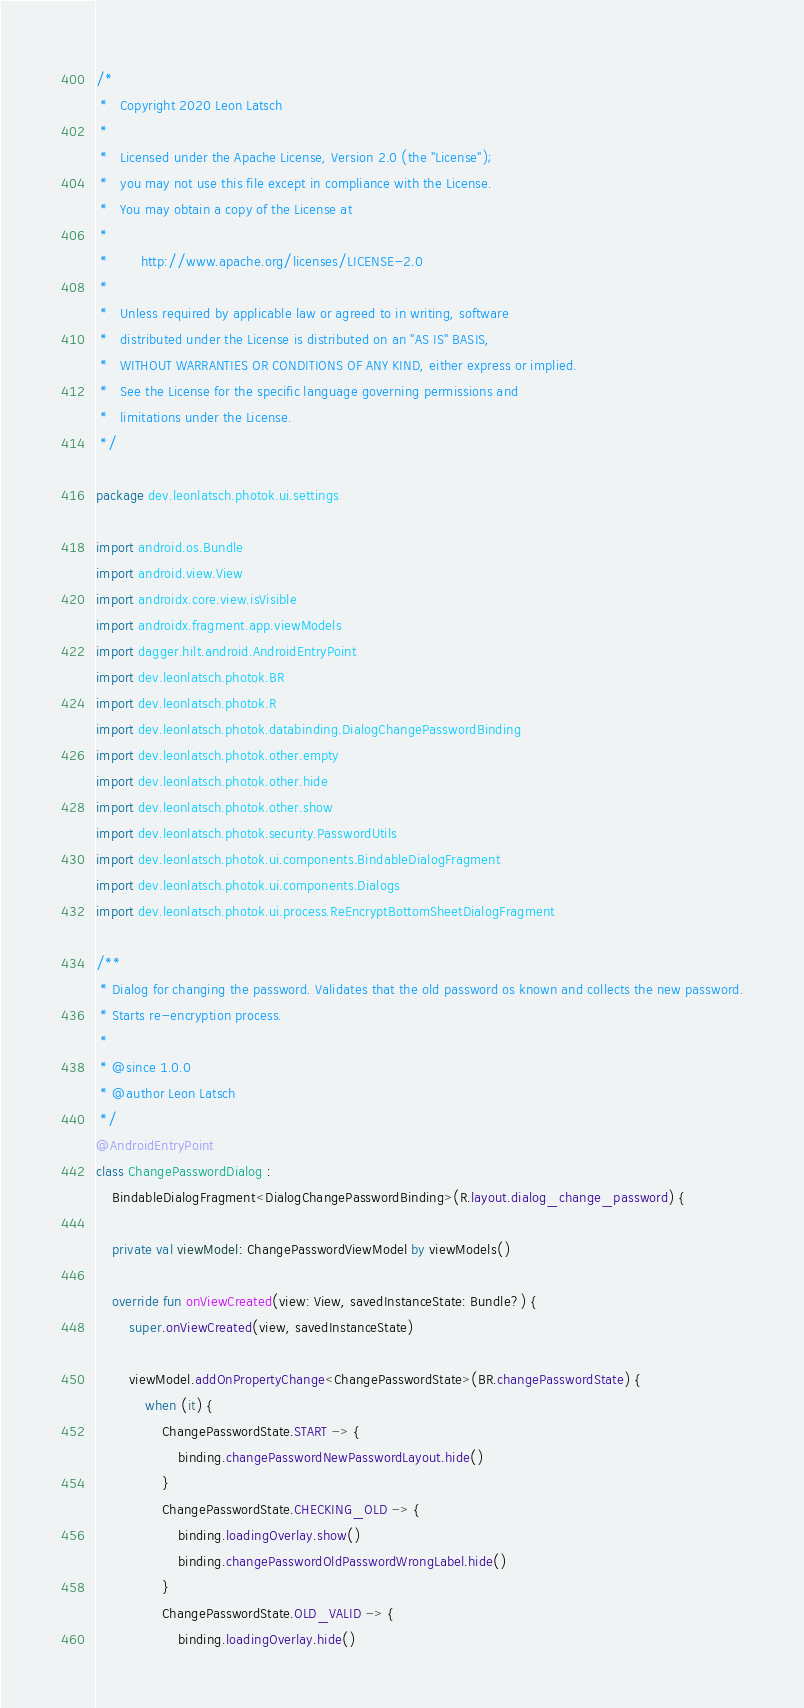Convert code to text. <code><loc_0><loc_0><loc_500><loc_500><_Kotlin_>/*
 *   Copyright 2020 Leon Latsch
 *
 *   Licensed under the Apache License, Version 2.0 (the "License");
 *   you may not use this file except in compliance with the License.
 *   You may obtain a copy of the License at
 *
 *        http://www.apache.org/licenses/LICENSE-2.0
 *
 *   Unless required by applicable law or agreed to in writing, software
 *   distributed under the License is distributed on an "AS IS" BASIS,
 *   WITHOUT WARRANTIES OR CONDITIONS OF ANY KIND, either express or implied.
 *   See the License for the specific language governing permissions and
 *   limitations under the License.
 */

package dev.leonlatsch.photok.ui.settings

import android.os.Bundle
import android.view.View
import androidx.core.view.isVisible
import androidx.fragment.app.viewModels
import dagger.hilt.android.AndroidEntryPoint
import dev.leonlatsch.photok.BR
import dev.leonlatsch.photok.R
import dev.leonlatsch.photok.databinding.DialogChangePasswordBinding
import dev.leonlatsch.photok.other.empty
import dev.leonlatsch.photok.other.hide
import dev.leonlatsch.photok.other.show
import dev.leonlatsch.photok.security.PasswordUtils
import dev.leonlatsch.photok.ui.components.BindableDialogFragment
import dev.leonlatsch.photok.ui.components.Dialogs
import dev.leonlatsch.photok.ui.process.ReEncryptBottomSheetDialogFragment

/**
 * Dialog for changing the password. Validates that the old password os known and collects the new password.
 * Starts re-encryption process.
 *
 * @since 1.0.0
 * @author Leon Latsch
 */
@AndroidEntryPoint
class ChangePasswordDialog :
    BindableDialogFragment<DialogChangePasswordBinding>(R.layout.dialog_change_password) {

    private val viewModel: ChangePasswordViewModel by viewModels()

    override fun onViewCreated(view: View, savedInstanceState: Bundle?) {
        super.onViewCreated(view, savedInstanceState)

        viewModel.addOnPropertyChange<ChangePasswordState>(BR.changePasswordState) {
            when (it) {
                ChangePasswordState.START -> {
                    binding.changePasswordNewPasswordLayout.hide()
                }
                ChangePasswordState.CHECKING_OLD -> {
                    binding.loadingOverlay.show()
                    binding.changePasswordOldPasswordWrongLabel.hide()
                }
                ChangePasswordState.OLD_VALID -> {
                    binding.loadingOverlay.hide()</code> 